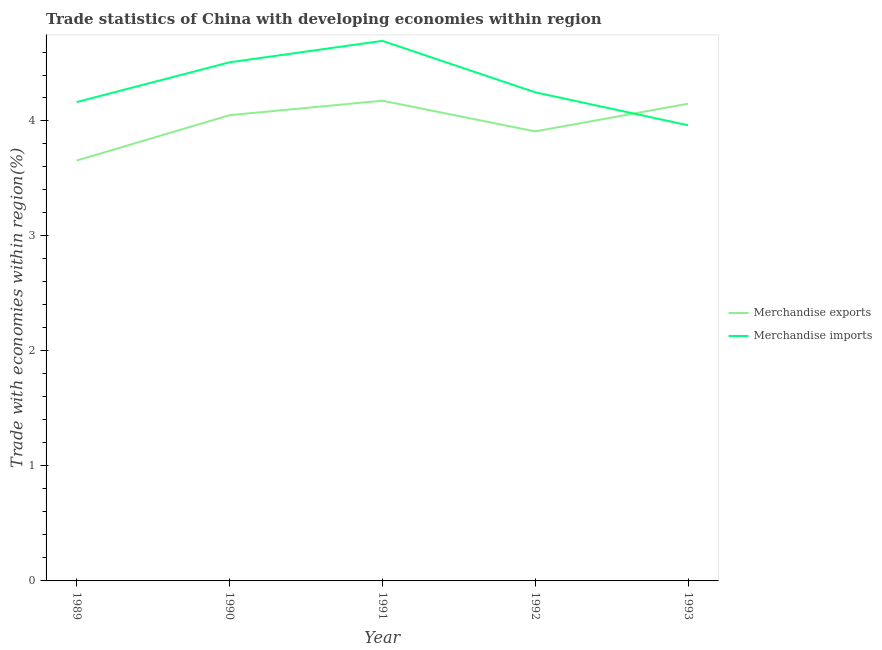Does the line corresponding to merchandise exports intersect with the line corresponding to merchandise imports?
Give a very brief answer. Yes. Is the number of lines equal to the number of legend labels?
Offer a terse response. Yes. What is the merchandise exports in 1993?
Make the answer very short. 4.15. Across all years, what is the maximum merchandise exports?
Your answer should be very brief. 4.18. Across all years, what is the minimum merchandise exports?
Keep it short and to the point. 3.66. In which year was the merchandise exports minimum?
Give a very brief answer. 1989. What is the total merchandise imports in the graph?
Your response must be concise. 21.58. What is the difference between the merchandise imports in 1989 and that in 1990?
Provide a short and direct response. -0.35. What is the difference between the merchandise exports in 1989 and the merchandise imports in 1992?
Keep it short and to the point. -0.59. What is the average merchandise imports per year?
Offer a very short reply. 4.32. In the year 1991, what is the difference between the merchandise exports and merchandise imports?
Provide a short and direct response. -0.52. What is the ratio of the merchandise exports in 1990 to that in 1993?
Offer a very short reply. 0.98. Is the difference between the merchandise imports in 1990 and 1993 greater than the difference between the merchandise exports in 1990 and 1993?
Your answer should be compact. Yes. What is the difference between the highest and the second highest merchandise exports?
Keep it short and to the point. 0.03. What is the difference between the highest and the lowest merchandise exports?
Ensure brevity in your answer.  0.52. Is the merchandise exports strictly less than the merchandise imports over the years?
Give a very brief answer. No. How many lines are there?
Provide a short and direct response. 2. How many years are there in the graph?
Keep it short and to the point. 5. What is the difference between two consecutive major ticks on the Y-axis?
Your answer should be very brief. 1. How many legend labels are there?
Keep it short and to the point. 2. What is the title of the graph?
Your answer should be compact. Trade statistics of China with developing economies within region. What is the label or title of the Y-axis?
Your response must be concise. Trade with economies within region(%). What is the Trade with economies within region(%) of Merchandise exports in 1989?
Provide a succinct answer. 3.66. What is the Trade with economies within region(%) of Merchandise imports in 1989?
Your answer should be very brief. 4.16. What is the Trade with economies within region(%) in Merchandise exports in 1990?
Your response must be concise. 4.05. What is the Trade with economies within region(%) in Merchandise imports in 1990?
Offer a very short reply. 4.51. What is the Trade with economies within region(%) of Merchandise exports in 1991?
Provide a succinct answer. 4.18. What is the Trade with economies within region(%) in Merchandise imports in 1991?
Give a very brief answer. 4.7. What is the Trade with economies within region(%) in Merchandise exports in 1992?
Ensure brevity in your answer.  3.91. What is the Trade with economies within region(%) of Merchandise imports in 1992?
Make the answer very short. 4.25. What is the Trade with economies within region(%) in Merchandise exports in 1993?
Offer a terse response. 4.15. What is the Trade with economies within region(%) in Merchandise imports in 1993?
Ensure brevity in your answer.  3.96. Across all years, what is the maximum Trade with economies within region(%) of Merchandise exports?
Your response must be concise. 4.18. Across all years, what is the maximum Trade with economies within region(%) of Merchandise imports?
Make the answer very short. 4.7. Across all years, what is the minimum Trade with economies within region(%) of Merchandise exports?
Your answer should be very brief. 3.66. Across all years, what is the minimum Trade with economies within region(%) in Merchandise imports?
Your answer should be compact. 3.96. What is the total Trade with economies within region(%) in Merchandise exports in the graph?
Your answer should be very brief. 19.94. What is the total Trade with economies within region(%) in Merchandise imports in the graph?
Ensure brevity in your answer.  21.58. What is the difference between the Trade with economies within region(%) in Merchandise exports in 1989 and that in 1990?
Offer a terse response. -0.39. What is the difference between the Trade with economies within region(%) in Merchandise imports in 1989 and that in 1990?
Offer a very short reply. -0.35. What is the difference between the Trade with economies within region(%) in Merchandise exports in 1989 and that in 1991?
Offer a very short reply. -0.52. What is the difference between the Trade with economies within region(%) in Merchandise imports in 1989 and that in 1991?
Make the answer very short. -0.53. What is the difference between the Trade with economies within region(%) in Merchandise exports in 1989 and that in 1992?
Keep it short and to the point. -0.25. What is the difference between the Trade with economies within region(%) of Merchandise imports in 1989 and that in 1992?
Provide a short and direct response. -0.09. What is the difference between the Trade with economies within region(%) of Merchandise exports in 1989 and that in 1993?
Make the answer very short. -0.49. What is the difference between the Trade with economies within region(%) of Merchandise imports in 1989 and that in 1993?
Ensure brevity in your answer.  0.2. What is the difference between the Trade with economies within region(%) of Merchandise exports in 1990 and that in 1991?
Give a very brief answer. -0.13. What is the difference between the Trade with economies within region(%) of Merchandise imports in 1990 and that in 1991?
Keep it short and to the point. -0.19. What is the difference between the Trade with economies within region(%) in Merchandise exports in 1990 and that in 1992?
Your response must be concise. 0.14. What is the difference between the Trade with economies within region(%) of Merchandise imports in 1990 and that in 1992?
Your response must be concise. 0.26. What is the difference between the Trade with economies within region(%) of Merchandise exports in 1990 and that in 1993?
Your answer should be very brief. -0.1. What is the difference between the Trade with economies within region(%) in Merchandise imports in 1990 and that in 1993?
Ensure brevity in your answer.  0.55. What is the difference between the Trade with economies within region(%) in Merchandise exports in 1991 and that in 1992?
Keep it short and to the point. 0.27. What is the difference between the Trade with economies within region(%) in Merchandise imports in 1991 and that in 1992?
Make the answer very short. 0.45. What is the difference between the Trade with economies within region(%) in Merchandise exports in 1991 and that in 1993?
Make the answer very short. 0.03. What is the difference between the Trade with economies within region(%) in Merchandise imports in 1991 and that in 1993?
Provide a succinct answer. 0.73. What is the difference between the Trade with economies within region(%) of Merchandise exports in 1992 and that in 1993?
Your answer should be compact. -0.24. What is the difference between the Trade with economies within region(%) in Merchandise imports in 1992 and that in 1993?
Your answer should be very brief. 0.29. What is the difference between the Trade with economies within region(%) in Merchandise exports in 1989 and the Trade with economies within region(%) in Merchandise imports in 1990?
Give a very brief answer. -0.85. What is the difference between the Trade with economies within region(%) of Merchandise exports in 1989 and the Trade with economies within region(%) of Merchandise imports in 1991?
Ensure brevity in your answer.  -1.04. What is the difference between the Trade with economies within region(%) of Merchandise exports in 1989 and the Trade with economies within region(%) of Merchandise imports in 1992?
Your answer should be very brief. -0.59. What is the difference between the Trade with economies within region(%) of Merchandise exports in 1989 and the Trade with economies within region(%) of Merchandise imports in 1993?
Ensure brevity in your answer.  -0.31. What is the difference between the Trade with economies within region(%) of Merchandise exports in 1990 and the Trade with economies within region(%) of Merchandise imports in 1991?
Offer a terse response. -0.65. What is the difference between the Trade with economies within region(%) of Merchandise exports in 1990 and the Trade with economies within region(%) of Merchandise imports in 1992?
Offer a very short reply. -0.2. What is the difference between the Trade with economies within region(%) in Merchandise exports in 1990 and the Trade with economies within region(%) in Merchandise imports in 1993?
Offer a very short reply. 0.09. What is the difference between the Trade with economies within region(%) in Merchandise exports in 1991 and the Trade with economies within region(%) in Merchandise imports in 1992?
Offer a terse response. -0.07. What is the difference between the Trade with economies within region(%) in Merchandise exports in 1991 and the Trade with economies within region(%) in Merchandise imports in 1993?
Offer a terse response. 0.21. What is the difference between the Trade with economies within region(%) in Merchandise exports in 1992 and the Trade with economies within region(%) in Merchandise imports in 1993?
Your answer should be compact. -0.05. What is the average Trade with economies within region(%) of Merchandise exports per year?
Ensure brevity in your answer.  3.99. What is the average Trade with economies within region(%) of Merchandise imports per year?
Provide a succinct answer. 4.32. In the year 1989, what is the difference between the Trade with economies within region(%) of Merchandise exports and Trade with economies within region(%) of Merchandise imports?
Your answer should be compact. -0.51. In the year 1990, what is the difference between the Trade with economies within region(%) of Merchandise exports and Trade with economies within region(%) of Merchandise imports?
Make the answer very short. -0.46. In the year 1991, what is the difference between the Trade with economies within region(%) in Merchandise exports and Trade with economies within region(%) in Merchandise imports?
Offer a terse response. -0.52. In the year 1992, what is the difference between the Trade with economies within region(%) of Merchandise exports and Trade with economies within region(%) of Merchandise imports?
Ensure brevity in your answer.  -0.34. In the year 1993, what is the difference between the Trade with economies within region(%) in Merchandise exports and Trade with economies within region(%) in Merchandise imports?
Keep it short and to the point. 0.19. What is the ratio of the Trade with economies within region(%) in Merchandise exports in 1989 to that in 1990?
Make the answer very short. 0.9. What is the ratio of the Trade with economies within region(%) of Merchandise imports in 1989 to that in 1990?
Offer a terse response. 0.92. What is the ratio of the Trade with economies within region(%) of Merchandise exports in 1989 to that in 1991?
Your answer should be very brief. 0.88. What is the ratio of the Trade with economies within region(%) of Merchandise imports in 1989 to that in 1991?
Ensure brevity in your answer.  0.89. What is the ratio of the Trade with economies within region(%) of Merchandise exports in 1989 to that in 1992?
Make the answer very short. 0.94. What is the ratio of the Trade with economies within region(%) in Merchandise imports in 1989 to that in 1992?
Keep it short and to the point. 0.98. What is the ratio of the Trade with economies within region(%) in Merchandise exports in 1989 to that in 1993?
Offer a very short reply. 0.88. What is the ratio of the Trade with economies within region(%) in Merchandise imports in 1989 to that in 1993?
Ensure brevity in your answer.  1.05. What is the ratio of the Trade with economies within region(%) in Merchandise exports in 1990 to that in 1991?
Keep it short and to the point. 0.97. What is the ratio of the Trade with economies within region(%) in Merchandise imports in 1990 to that in 1991?
Provide a succinct answer. 0.96. What is the ratio of the Trade with economies within region(%) in Merchandise exports in 1990 to that in 1992?
Your answer should be very brief. 1.04. What is the ratio of the Trade with economies within region(%) in Merchandise imports in 1990 to that in 1992?
Give a very brief answer. 1.06. What is the ratio of the Trade with economies within region(%) of Merchandise exports in 1990 to that in 1993?
Keep it short and to the point. 0.98. What is the ratio of the Trade with economies within region(%) of Merchandise imports in 1990 to that in 1993?
Offer a terse response. 1.14. What is the ratio of the Trade with economies within region(%) in Merchandise exports in 1991 to that in 1992?
Ensure brevity in your answer.  1.07. What is the ratio of the Trade with economies within region(%) of Merchandise imports in 1991 to that in 1992?
Make the answer very short. 1.11. What is the ratio of the Trade with economies within region(%) in Merchandise exports in 1991 to that in 1993?
Provide a short and direct response. 1.01. What is the ratio of the Trade with economies within region(%) of Merchandise imports in 1991 to that in 1993?
Keep it short and to the point. 1.19. What is the ratio of the Trade with economies within region(%) of Merchandise exports in 1992 to that in 1993?
Provide a short and direct response. 0.94. What is the ratio of the Trade with economies within region(%) in Merchandise imports in 1992 to that in 1993?
Keep it short and to the point. 1.07. What is the difference between the highest and the second highest Trade with economies within region(%) of Merchandise exports?
Offer a terse response. 0.03. What is the difference between the highest and the second highest Trade with economies within region(%) in Merchandise imports?
Offer a very short reply. 0.19. What is the difference between the highest and the lowest Trade with economies within region(%) in Merchandise exports?
Offer a very short reply. 0.52. What is the difference between the highest and the lowest Trade with economies within region(%) in Merchandise imports?
Offer a terse response. 0.73. 